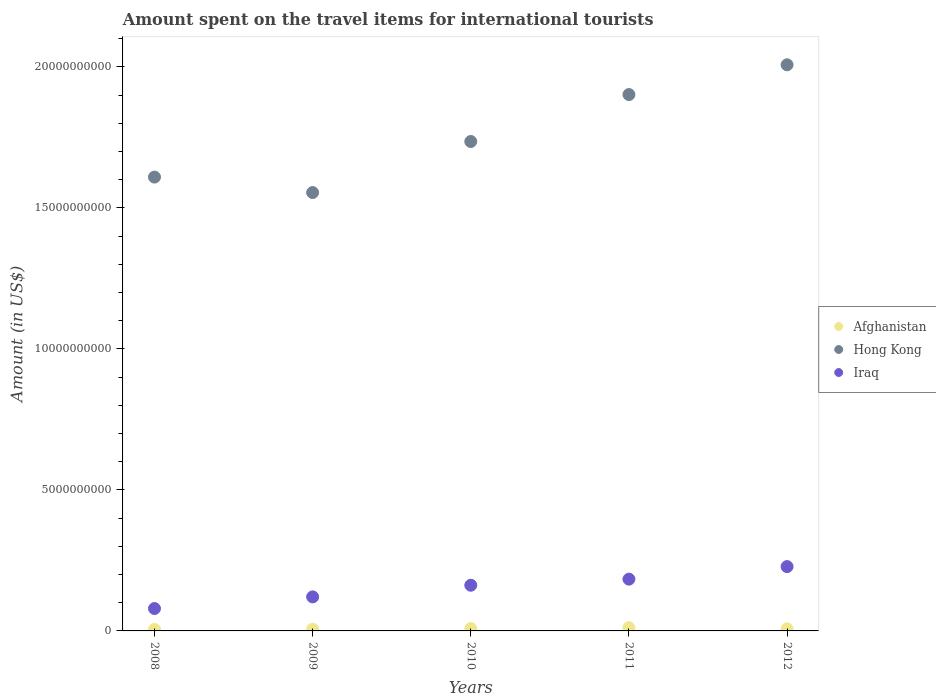How many different coloured dotlines are there?
Offer a terse response. 3. Is the number of dotlines equal to the number of legend labels?
Your answer should be compact. Yes. What is the amount spent on the travel items for international tourists in Iraq in 2012?
Your answer should be compact. 2.28e+09. Across all years, what is the maximum amount spent on the travel items for international tourists in Iraq?
Your answer should be compact. 2.28e+09. Across all years, what is the minimum amount spent on the travel items for international tourists in Hong Kong?
Your response must be concise. 1.55e+1. In which year was the amount spent on the travel items for international tourists in Iraq maximum?
Your response must be concise. 2012. What is the total amount spent on the travel items for international tourists in Afghanistan in the graph?
Ensure brevity in your answer.  3.85e+08. What is the difference between the amount spent on the travel items for international tourists in Afghanistan in 2010 and that in 2012?
Ensure brevity in your answer.  8.00e+06. What is the difference between the amount spent on the travel items for international tourists in Hong Kong in 2012 and the amount spent on the travel items for international tourists in Afghanistan in 2008?
Keep it short and to the point. 2.00e+1. What is the average amount spent on the travel items for international tourists in Afghanistan per year?
Provide a short and direct response. 7.70e+07. In the year 2008, what is the difference between the amount spent on the travel items for international tourists in Afghanistan and amount spent on the travel items for international tourists in Iraq?
Keep it short and to the point. -7.39e+08. In how many years, is the amount spent on the travel items for international tourists in Afghanistan greater than 5000000000 US$?
Provide a short and direct response. 0. What is the ratio of the amount spent on the travel items for international tourists in Afghanistan in 2009 to that in 2010?
Make the answer very short. 0.71. What is the difference between the highest and the second highest amount spent on the travel items for international tourists in Hong Kong?
Your response must be concise. 1.06e+09. What is the difference between the highest and the lowest amount spent on the travel items for international tourists in Iraq?
Give a very brief answer. 1.49e+09. Is the sum of the amount spent on the travel items for international tourists in Afghanistan in 2009 and 2011 greater than the maximum amount spent on the travel items for international tourists in Iraq across all years?
Offer a very short reply. No. Is it the case that in every year, the sum of the amount spent on the travel items for international tourists in Hong Kong and amount spent on the travel items for international tourists in Iraq  is greater than the amount spent on the travel items for international tourists in Afghanistan?
Provide a succinct answer. Yes. Does the amount spent on the travel items for international tourists in Afghanistan monotonically increase over the years?
Ensure brevity in your answer.  No. Is the amount spent on the travel items for international tourists in Afghanistan strictly greater than the amount spent on the travel items for international tourists in Iraq over the years?
Offer a very short reply. No. Is the amount spent on the travel items for international tourists in Iraq strictly less than the amount spent on the travel items for international tourists in Afghanistan over the years?
Your response must be concise. No. Are the values on the major ticks of Y-axis written in scientific E-notation?
Offer a terse response. No. Where does the legend appear in the graph?
Make the answer very short. Center right. How many legend labels are there?
Offer a terse response. 3. What is the title of the graph?
Make the answer very short. Amount spent on the travel items for international tourists. What is the label or title of the X-axis?
Your answer should be compact. Years. What is the label or title of the Y-axis?
Offer a very short reply. Amount (in US$). What is the Amount (in US$) in Afghanistan in 2008?
Make the answer very short. 5.50e+07. What is the Amount (in US$) of Hong Kong in 2008?
Offer a very short reply. 1.61e+1. What is the Amount (in US$) of Iraq in 2008?
Your answer should be compact. 7.94e+08. What is the Amount (in US$) in Afghanistan in 2009?
Offer a very short reply. 5.90e+07. What is the Amount (in US$) in Hong Kong in 2009?
Your answer should be compact. 1.55e+1. What is the Amount (in US$) in Iraq in 2009?
Make the answer very short. 1.21e+09. What is the Amount (in US$) of Afghanistan in 2010?
Provide a short and direct response. 8.30e+07. What is the Amount (in US$) of Hong Kong in 2010?
Your response must be concise. 1.74e+1. What is the Amount (in US$) of Iraq in 2010?
Offer a terse response. 1.62e+09. What is the Amount (in US$) in Afghanistan in 2011?
Keep it short and to the point. 1.13e+08. What is the Amount (in US$) of Hong Kong in 2011?
Offer a terse response. 1.90e+1. What is the Amount (in US$) in Iraq in 2011?
Keep it short and to the point. 1.84e+09. What is the Amount (in US$) in Afghanistan in 2012?
Give a very brief answer. 7.50e+07. What is the Amount (in US$) of Hong Kong in 2012?
Make the answer very short. 2.01e+1. What is the Amount (in US$) in Iraq in 2012?
Provide a short and direct response. 2.28e+09. Across all years, what is the maximum Amount (in US$) of Afghanistan?
Ensure brevity in your answer.  1.13e+08. Across all years, what is the maximum Amount (in US$) of Hong Kong?
Offer a very short reply. 2.01e+1. Across all years, what is the maximum Amount (in US$) of Iraq?
Ensure brevity in your answer.  2.28e+09. Across all years, what is the minimum Amount (in US$) in Afghanistan?
Your response must be concise. 5.50e+07. Across all years, what is the minimum Amount (in US$) of Hong Kong?
Offer a terse response. 1.55e+1. Across all years, what is the minimum Amount (in US$) in Iraq?
Offer a terse response. 7.94e+08. What is the total Amount (in US$) of Afghanistan in the graph?
Give a very brief answer. 3.85e+08. What is the total Amount (in US$) of Hong Kong in the graph?
Ensure brevity in your answer.  8.81e+1. What is the total Amount (in US$) of Iraq in the graph?
Provide a succinct answer. 7.74e+09. What is the difference between the Amount (in US$) of Afghanistan in 2008 and that in 2009?
Ensure brevity in your answer.  -4.00e+06. What is the difference between the Amount (in US$) in Hong Kong in 2008 and that in 2009?
Your answer should be very brief. 5.48e+08. What is the difference between the Amount (in US$) of Iraq in 2008 and that in 2009?
Make the answer very short. -4.13e+08. What is the difference between the Amount (in US$) in Afghanistan in 2008 and that in 2010?
Provide a short and direct response. -2.80e+07. What is the difference between the Amount (in US$) in Hong Kong in 2008 and that in 2010?
Ensure brevity in your answer.  -1.26e+09. What is the difference between the Amount (in US$) in Iraq in 2008 and that in 2010?
Provide a short and direct response. -8.26e+08. What is the difference between the Amount (in US$) in Afghanistan in 2008 and that in 2011?
Ensure brevity in your answer.  -5.80e+07. What is the difference between the Amount (in US$) of Hong Kong in 2008 and that in 2011?
Ensure brevity in your answer.  -2.93e+09. What is the difference between the Amount (in US$) of Iraq in 2008 and that in 2011?
Offer a terse response. -1.04e+09. What is the difference between the Amount (in US$) in Afghanistan in 2008 and that in 2012?
Provide a short and direct response. -2.00e+07. What is the difference between the Amount (in US$) of Hong Kong in 2008 and that in 2012?
Your answer should be compact. -3.98e+09. What is the difference between the Amount (in US$) of Iraq in 2008 and that in 2012?
Ensure brevity in your answer.  -1.49e+09. What is the difference between the Amount (in US$) in Afghanistan in 2009 and that in 2010?
Ensure brevity in your answer.  -2.40e+07. What is the difference between the Amount (in US$) in Hong Kong in 2009 and that in 2010?
Offer a very short reply. -1.81e+09. What is the difference between the Amount (in US$) in Iraq in 2009 and that in 2010?
Keep it short and to the point. -4.13e+08. What is the difference between the Amount (in US$) in Afghanistan in 2009 and that in 2011?
Provide a succinct answer. -5.40e+07. What is the difference between the Amount (in US$) in Hong Kong in 2009 and that in 2011?
Your response must be concise. -3.48e+09. What is the difference between the Amount (in US$) of Iraq in 2009 and that in 2011?
Make the answer very short. -6.29e+08. What is the difference between the Amount (in US$) in Afghanistan in 2009 and that in 2012?
Provide a succinct answer. -1.60e+07. What is the difference between the Amount (in US$) in Hong Kong in 2009 and that in 2012?
Provide a short and direct response. -4.53e+09. What is the difference between the Amount (in US$) of Iraq in 2009 and that in 2012?
Your answer should be very brief. -1.07e+09. What is the difference between the Amount (in US$) of Afghanistan in 2010 and that in 2011?
Your answer should be compact. -3.00e+07. What is the difference between the Amount (in US$) of Hong Kong in 2010 and that in 2011?
Your answer should be very brief. -1.66e+09. What is the difference between the Amount (in US$) of Iraq in 2010 and that in 2011?
Provide a succinct answer. -2.16e+08. What is the difference between the Amount (in US$) in Afghanistan in 2010 and that in 2012?
Make the answer very short. 8.00e+06. What is the difference between the Amount (in US$) of Hong Kong in 2010 and that in 2012?
Ensure brevity in your answer.  -2.72e+09. What is the difference between the Amount (in US$) of Iraq in 2010 and that in 2012?
Make the answer very short. -6.61e+08. What is the difference between the Amount (in US$) in Afghanistan in 2011 and that in 2012?
Give a very brief answer. 3.80e+07. What is the difference between the Amount (in US$) of Hong Kong in 2011 and that in 2012?
Offer a terse response. -1.06e+09. What is the difference between the Amount (in US$) of Iraq in 2011 and that in 2012?
Keep it short and to the point. -4.45e+08. What is the difference between the Amount (in US$) of Afghanistan in 2008 and the Amount (in US$) of Hong Kong in 2009?
Provide a succinct answer. -1.55e+1. What is the difference between the Amount (in US$) of Afghanistan in 2008 and the Amount (in US$) of Iraq in 2009?
Make the answer very short. -1.15e+09. What is the difference between the Amount (in US$) in Hong Kong in 2008 and the Amount (in US$) in Iraq in 2009?
Offer a very short reply. 1.49e+1. What is the difference between the Amount (in US$) in Afghanistan in 2008 and the Amount (in US$) in Hong Kong in 2010?
Provide a short and direct response. -1.73e+1. What is the difference between the Amount (in US$) in Afghanistan in 2008 and the Amount (in US$) in Iraq in 2010?
Give a very brief answer. -1.56e+09. What is the difference between the Amount (in US$) of Hong Kong in 2008 and the Amount (in US$) of Iraq in 2010?
Your response must be concise. 1.45e+1. What is the difference between the Amount (in US$) of Afghanistan in 2008 and the Amount (in US$) of Hong Kong in 2011?
Give a very brief answer. -1.90e+1. What is the difference between the Amount (in US$) in Afghanistan in 2008 and the Amount (in US$) in Iraq in 2011?
Offer a very short reply. -1.78e+09. What is the difference between the Amount (in US$) of Hong Kong in 2008 and the Amount (in US$) of Iraq in 2011?
Make the answer very short. 1.43e+1. What is the difference between the Amount (in US$) of Afghanistan in 2008 and the Amount (in US$) of Hong Kong in 2012?
Provide a short and direct response. -2.00e+1. What is the difference between the Amount (in US$) in Afghanistan in 2008 and the Amount (in US$) in Iraq in 2012?
Keep it short and to the point. -2.23e+09. What is the difference between the Amount (in US$) in Hong Kong in 2008 and the Amount (in US$) in Iraq in 2012?
Provide a short and direct response. 1.38e+1. What is the difference between the Amount (in US$) in Afghanistan in 2009 and the Amount (in US$) in Hong Kong in 2010?
Give a very brief answer. -1.73e+1. What is the difference between the Amount (in US$) in Afghanistan in 2009 and the Amount (in US$) in Iraq in 2010?
Ensure brevity in your answer.  -1.56e+09. What is the difference between the Amount (in US$) of Hong Kong in 2009 and the Amount (in US$) of Iraq in 2010?
Your answer should be compact. 1.39e+1. What is the difference between the Amount (in US$) in Afghanistan in 2009 and the Amount (in US$) in Hong Kong in 2011?
Your answer should be compact. -1.90e+1. What is the difference between the Amount (in US$) in Afghanistan in 2009 and the Amount (in US$) in Iraq in 2011?
Keep it short and to the point. -1.78e+09. What is the difference between the Amount (in US$) in Hong Kong in 2009 and the Amount (in US$) in Iraq in 2011?
Offer a terse response. 1.37e+1. What is the difference between the Amount (in US$) in Afghanistan in 2009 and the Amount (in US$) in Hong Kong in 2012?
Provide a succinct answer. -2.00e+1. What is the difference between the Amount (in US$) in Afghanistan in 2009 and the Amount (in US$) in Iraq in 2012?
Offer a terse response. -2.22e+09. What is the difference between the Amount (in US$) of Hong Kong in 2009 and the Amount (in US$) of Iraq in 2012?
Offer a very short reply. 1.33e+1. What is the difference between the Amount (in US$) in Afghanistan in 2010 and the Amount (in US$) in Hong Kong in 2011?
Your response must be concise. -1.89e+1. What is the difference between the Amount (in US$) in Afghanistan in 2010 and the Amount (in US$) in Iraq in 2011?
Your answer should be compact. -1.75e+09. What is the difference between the Amount (in US$) in Hong Kong in 2010 and the Amount (in US$) in Iraq in 2011?
Your response must be concise. 1.55e+1. What is the difference between the Amount (in US$) in Afghanistan in 2010 and the Amount (in US$) in Hong Kong in 2012?
Your answer should be very brief. -2.00e+1. What is the difference between the Amount (in US$) in Afghanistan in 2010 and the Amount (in US$) in Iraq in 2012?
Ensure brevity in your answer.  -2.20e+09. What is the difference between the Amount (in US$) of Hong Kong in 2010 and the Amount (in US$) of Iraq in 2012?
Your answer should be very brief. 1.51e+1. What is the difference between the Amount (in US$) in Afghanistan in 2011 and the Amount (in US$) in Hong Kong in 2012?
Your answer should be compact. -2.00e+1. What is the difference between the Amount (in US$) in Afghanistan in 2011 and the Amount (in US$) in Iraq in 2012?
Ensure brevity in your answer.  -2.17e+09. What is the difference between the Amount (in US$) in Hong Kong in 2011 and the Amount (in US$) in Iraq in 2012?
Provide a succinct answer. 1.67e+1. What is the average Amount (in US$) in Afghanistan per year?
Your answer should be compact. 7.70e+07. What is the average Amount (in US$) in Hong Kong per year?
Offer a very short reply. 1.76e+1. What is the average Amount (in US$) in Iraq per year?
Your answer should be very brief. 1.55e+09. In the year 2008, what is the difference between the Amount (in US$) of Afghanistan and Amount (in US$) of Hong Kong?
Make the answer very short. -1.60e+1. In the year 2008, what is the difference between the Amount (in US$) in Afghanistan and Amount (in US$) in Iraq?
Offer a very short reply. -7.39e+08. In the year 2008, what is the difference between the Amount (in US$) in Hong Kong and Amount (in US$) in Iraq?
Make the answer very short. 1.53e+1. In the year 2009, what is the difference between the Amount (in US$) of Afghanistan and Amount (in US$) of Hong Kong?
Provide a short and direct response. -1.55e+1. In the year 2009, what is the difference between the Amount (in US$) in Afghanistan and Amount (in US$) in Iraq?
Ensure brevity in your answer.  -1.15e+09. In the year 2009, what is the difference between the Amount (in US$) in Hong Kong and Amount (in US$) in Iraq?
Ensure brevity in your answer.  1.43e+1. In the year 2010, what is the difference between the Amount (in US$) of Afghanistan and Amount (in US$) of Hong Kong?
Your response must be concise. -1.73e+1. In the year 2010, what is the difference between the Amount (in US$) of Afghanistan and Amount (in US$) of Iraq?
Keep it short and to the point. -1.54e+09. In the year 2010, what is the difference between the Amount (in US$) in Hong Kong and Amount (in US$) in Iraq?
Keep it short and to the point. 1.57e+1. In the year 2011, what is the difference between the Amount (in US$) of Afghanistan and Amount (in US$) of Hong Kong?
Provide a succinct answer. -1.89e+1. In the year 2011, what is the difference between the Amount (in US$) of Afghanistan and Amount (in US$) of Iraq?
Offer a terse response. -1.72e+09. In the year 2011, what is the difference between the Amount (in US$) of Hong Kong and Amount (in US$) of Iraq?
Offer a very short reply. 1.72e+1. In the year 2012, what is the difference between the Amount (in US$) of Afghanistan and Amount (in US$) of Hong Kong?
Make the answer very short. -2.00e+1. In the year 2012, what is the difference between the Amount (in US$) in Afghanistan and Amount (in US$) in Iraq?
Offer a terse response. -2.21e+09. In the year 2012, what is the difference between the Amount (in US$) of Hong Kong and Amount (in US$) of Iraq?
Give a very brief answer. 1.78e+1. What is the ratio of the Amount (in US$) in Afghanistan in 2008 to that in 2009?
Your answer should be very brief. 0.93. What is the ratio of the Amount (in US$) in Hong Kong in 2008 to that in 2009?
Your response must be concise. 1.04. What is the ratio of the Amount (in US$) of Iraq in 2008 to that in 2009?
Keep it short and to the point. 0.66. What is the ratio of the Amount (in US$) of Afghanistan in 2008 to that in 2010?
Your response must be concise. 0.66. What is the ratio of the Amount (in US$) in Hong Kong in 2008 to that in 2010?
Keep it short and to the point. 0.93. What is the ratio of the Amount (in US$) of Iraq in 2008 to that in 2010?
Offer a terse response. 0.49. What is the ratio of the Amount (in US$) of Afghanistan in 2008 to that in 2011?
Provide a succinct answer. 0.49. What is the ratio of the Amount (in US$) of Hong Kong in 2008 to that in 2011?
Provide a short and direct response. 0.85. What is the ratio of the Amount (in US$) in Iraq in 2008 to that in 2011?
Your answer should be very brief. 0.43. What is the ratio of the Amount (in US$) in Afghanistan in 2008 to that in 2012?
Offer a very short reply. 0.73. What is the ratio of the Amount (in US$) in Hong Kong in 2008 to that in 2012?
Offer a terse response. 0.8. What is the ratio of the Amount (in US$) of Iraq in 2008 to that in 2012?
Your answer should be compact. 0.35. What is the ratio of the Amount (in US$) in Afghanistan in 2009 to that in 2010?
Provide a short and direct response. 0.71. What is the ratio of the Amount (in US$) in Hong Kong in 2009 to that in 2010?
Make the answer very short. 0.9. What is the ratio of the Amount (in US$) of Iraq in 2009 to that in 2010?
Your response must be concise. 0.75. What is the ratio of the Amount (in US$) in Afghanistan in 2009 to that in 2011?
Make the answer very short. 0.52. What is the ratio of the Amount (in US$) of Hong Kong in 2009 to that in 2011?
Give a very brief answer. 0.82. What is the ratio of the Amount (in US$) of Iraq in 2009 to that in 2011?
Offer a terse response. 0.66. What is the ratio of the Amount (in US$) of Afghanistan in 2009 to that in 2012?
Your response must be concise. 0.79. What is the ratio of the Amount (in US$) of Hong Kong in 2009 to that in 2012?
Your answer should be very brief. 0.77. What is the ratio of the Amount (in US$) of Iraq in 2009 to that in 2012?
Give a very brief answer. 0.53. What is the ratio of the Amount (in US$) in Afghanistan in 2010 to that in 2011?
Ensure brevity in your answer.  0.73. What is the ratio of the Amount (in US$) of Hong Kong in 2010 to that in 2011?
Your answer should be very brief. 0.91. What is the ratio of the Amount (in US$) of Iraq in 2010 to that in 2011?
Your answer should be very brief. 0.88. What is the ratio of the Amount (in US$) in Afghanistan in 2010 to that in 2012?
Provide a succinct answer. 1.11. What is the ratio of the Amount (in US$) of Hong Kong in 2010 to that in 2012?
Provide a succinct answer. 0.86. What is the ratio of the Amount (in US$) of Iraq in 2010 to that in 2012?
Your answer should be very brief. 0.71. What is the ratio of the Amount (in US$) of Afghanistan in 2011 to that in 2012?
Provide a short and direct response. 1.51. What is the ratio of the Amount (in US$) in Hong Kong in 2011 to that in 2012?
Keep it short and to the point. 0.95. What is the ratio of the Amount (in US$) of Iraq in 2011 to that in 2012?
Your answer should be compact. 0.8. What is the difference between the highest and the second highest Amount (in US$) of Afghanistan?
Offer a terse response. 3.00e+07. What is the difference between the highest and the second highest Amount (in US$) in Hong Kong?
Provide a succinct answer. 1.06e+09. What is the difference between the highest and the second highest Amount (in US$) of Iraq?
Offer a terse response. 4.45e+08. What is the difference between the highest and the lowest Amount (in US$) in Afghanistan?
Your answer should be compact. 5.80e+07. What is the difference between the highest and the lowest Amount (in US$) of Hong Kong?
Make the answer very short. 4.53e+09. What is the difference between the highest and the lowest Amount (in US$) in Iraq?
Offer a terse response. 1.49e+09. 